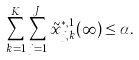Convert formula to latex. <formula><loc_0><loc_0><loc_500><loc_500>\sum _ { k = 1 } ^ { K } \sum _ { j = 1 } ^ { J _ { k } } \tilde { x } ^ { * , 1 } _ { j , k } ( \infty ) \leq \alpha .</formula> 